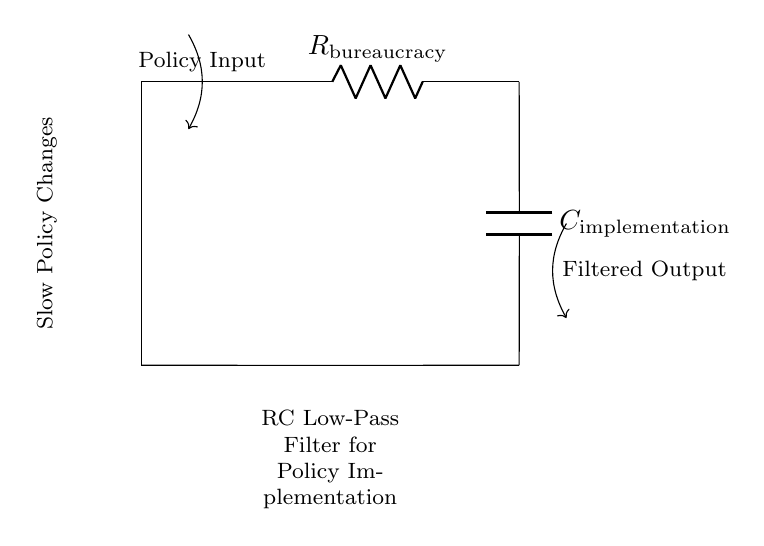What does the R component represent? The R component, labeled as R_bureaucracy, represents the resistance to change within the policy implementation process, implying the slow response to new ideas or policies.
Answer: R_bureaucracy What is the role of the C component? The C component, labeled as C_implementation, stores charge, which represents the accumulation of efforts required to implement policy changes over time, affecting the speed of policy adoption.
Answer: C_implementation What type of filter does this circuit represent? The circuit is an RC low-pass filter, which allows low-frequency signals (slow changes) to pass while attenuating high-frequency signals (rapid changes), analogous to gradual policy adaptation.
Answer: RC low-pass filter What does the input arrow denote? The input arrow labeled as Policy Input denotes the entry point for new policy ideas or changes that are to be filtered through the bureaucracy before being implemented.
Answer: Policy Input How does the filtered output relate to the input? The filtered output represents how many of the proposed policy changes are successfully implemented after passing through the bureaucracy, reflecting the delay created in the process.
Answer: Filtered Output What does a slow response in this circuit signify about policy changes? A slow response in this RC low-pass filter indicates that the policy changes are delayed and that the system takes time to adjust to new inputs, which can lead to missed opportunities for timely implementation.
Answer: Slow response How would increasing R affect the filter response? Increasing R would lead to a slower response time in the filter, representing a greater resistance to policy changes and potential delays in implementation, resulting in a longer time for new policies to take effect.
Answer: Slower response 